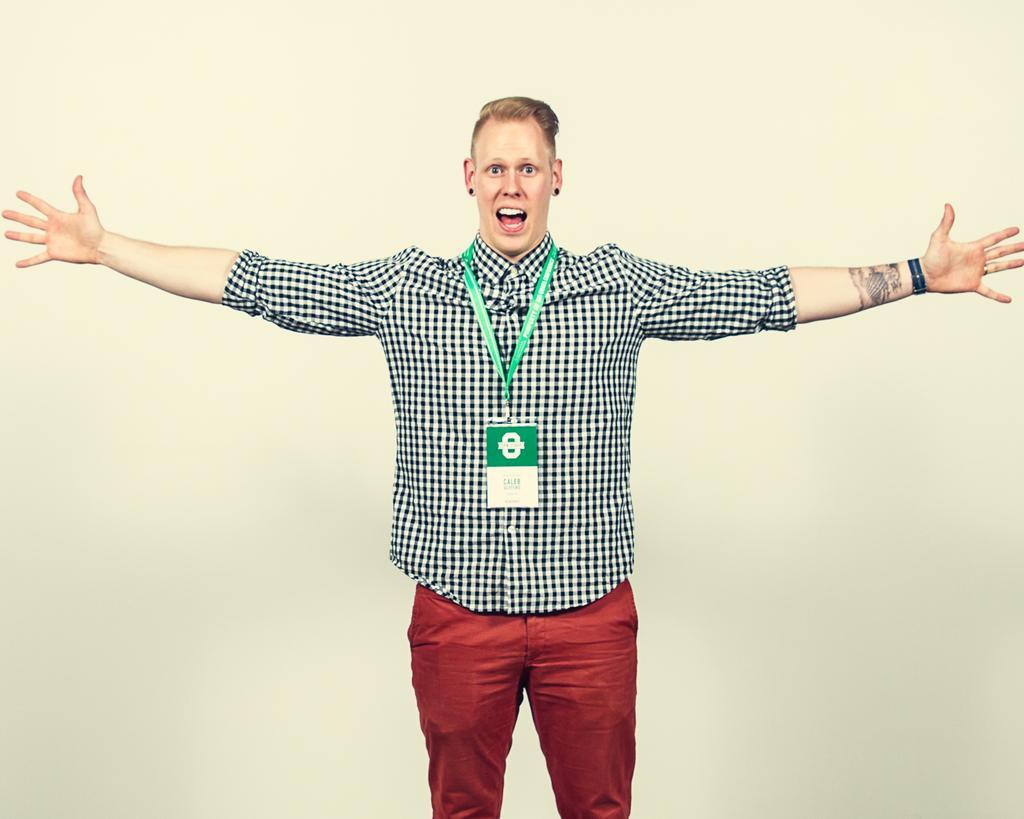In one or two sentences, can you explain what this image depicts? In this image I can see a person wearing black and white shirt and red color pant is standing. I can see the cream colored background. 